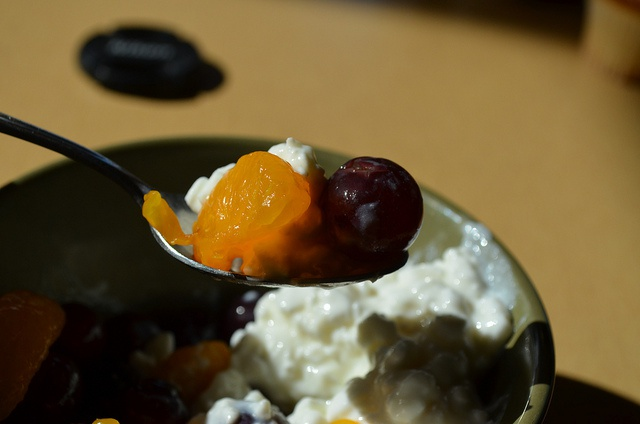Describe the objects in this image and their specific colors. I can see bowl in olive, black, lightgray, darkgray, and darkgreen tones, orange in olive and orange tones, and spoon in olive, black, gray, darkgray, and ivory tones in this image. 